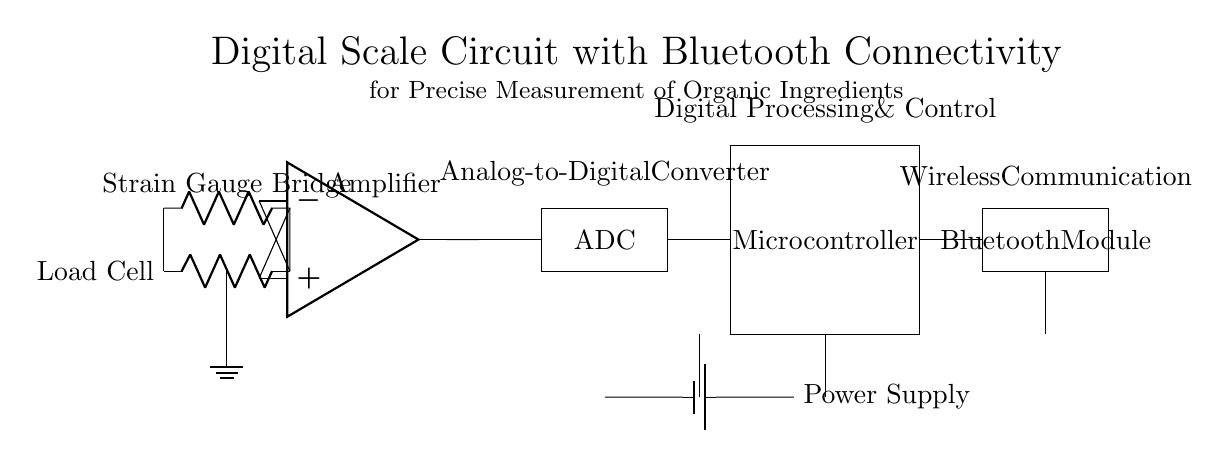What component detects weight in this circuit? The load cell detects weight by measuring the deformation caused by the load applied on it through the strain gauge bridge. This deformation generates a change in resistance, which is converted into a voltage signal.
Answer: Load Cell What type of amplifier is used in this circuit? The instrumentation amplifier is specifically designed for amplifying low-level signals from the load cell while rejecting common-mode noise, ensuring accurate measurement of weight.
Answer: Instrumentation Amplifier How is the weight measurement converted into a digital signal? The analog output from the instrumentation amplifier is fed into the analog-to-digital converter (ADC), which samples the analog voltage and converts it into a digital signal that the microcontroller can process.
Answer: ADC What is the purpose of the Bluetooth module in this circuit? The Bluetooth module is used for wireless communication to send the weight measurements from the microcontroller to a smartphone or other devices for monitoring or further processing.
Answer: Wireless Communication How many main blocks are there in this digital scale circuit? There are five main blocks: Load Cell, Instrumentation Amplifier, ADC, Microcontroller, and Bluetooth Module, which work together for precise measurement and data transmission.
Answer: Five Which component provides the power supply for the entire circuit? The power supply is provided by the battery, which supplies the necessary voltage and current to all components within the circuit.
Answer: Battery What type of bridge is part of the load cell? The strain gauge bridge is employed within the load cell to precisely measure the deformation caused by the applied load, which is critical for accurate weight measurement.
Answer: Strain Gauge Bridge 